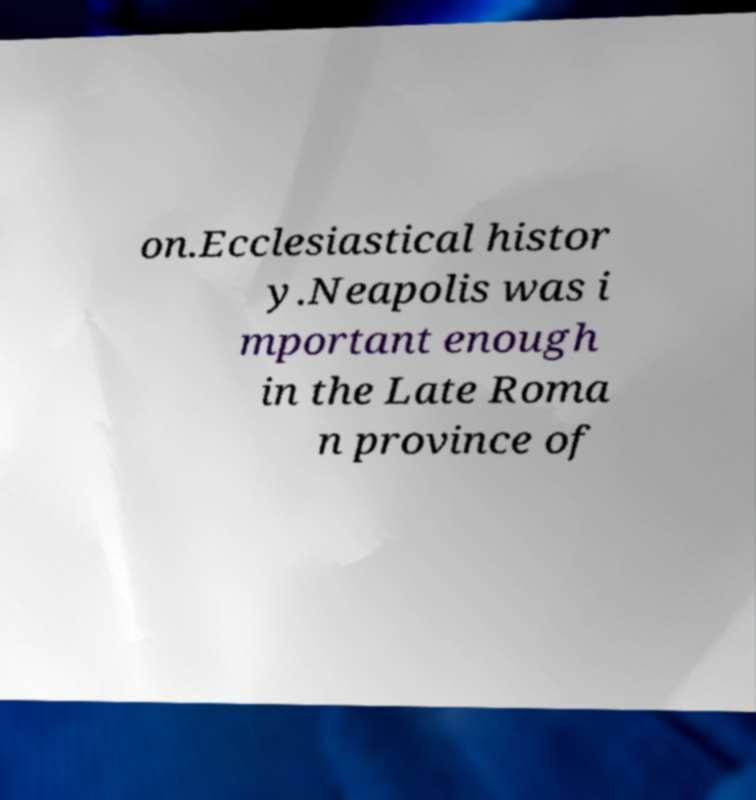For documentation purposes, I need the text within this image transcribed. Could you provide that? on.Ecclesiastical histor y.Neapolis was i mportant enough in the Late Roma n province of 